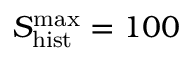<formula> <loc_0><loc_0><loc_500><loc_500>S _ { h i s t } ^ { \max } = 1 0 0</formula> 